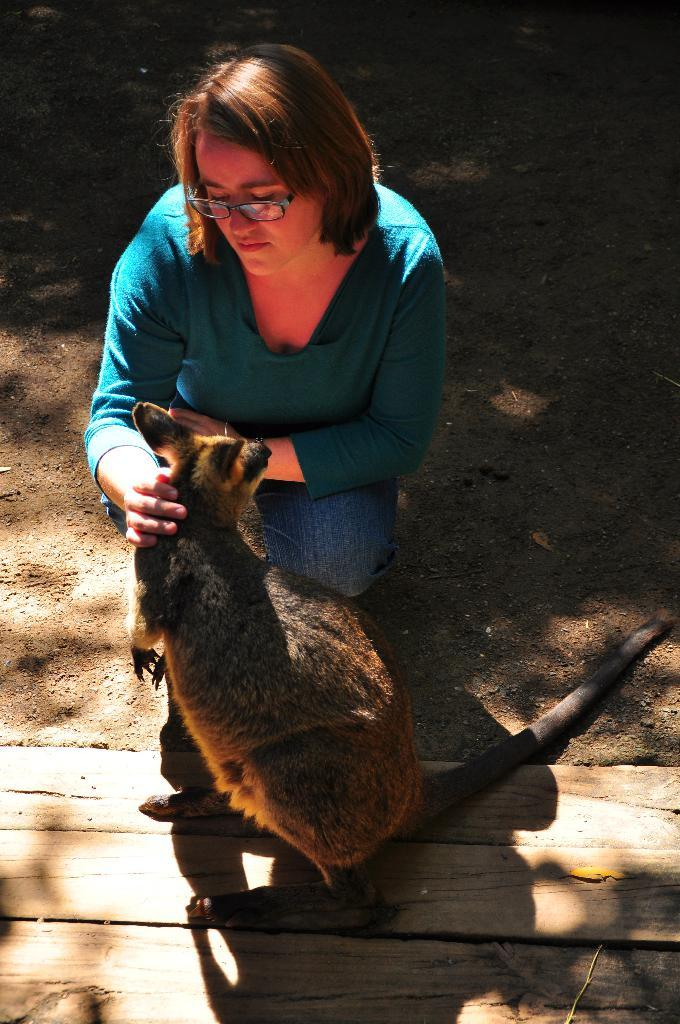What type of species can be seen in the image? There is a species in the image, but it is not specified which one. Who is present in the image besides the species? There is a woman in the image. What is the woman wearing on her face? The woman is wearing spectacles. What position does the camera hold in the image? There is no camera present in the image, so it cannot hold a position. Is there any lettuce visible in the image? There is no lettuce present in the image. 